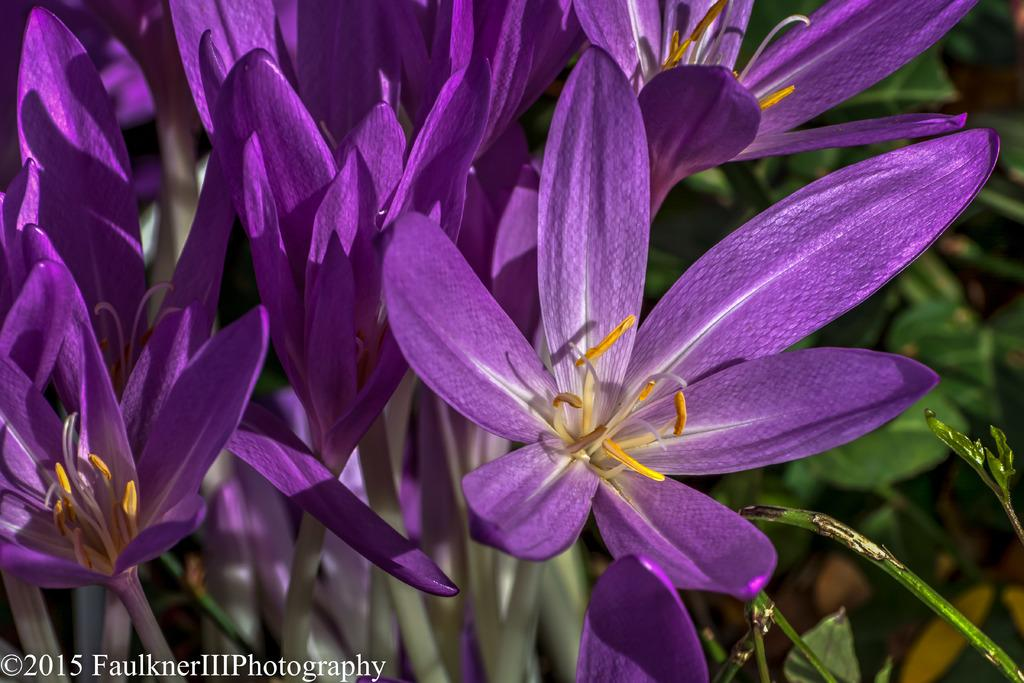What type of flora can be seen in the image? There are flowers in the image. What colors are the flowers? The flowers are violet, white, and yellow in color. What else can be seen in the background of the image? There are plants in the background of the image. What is the cause of the woman's laughter in the image? There is no woman present in the image, and therefore no laughter to analyze. 